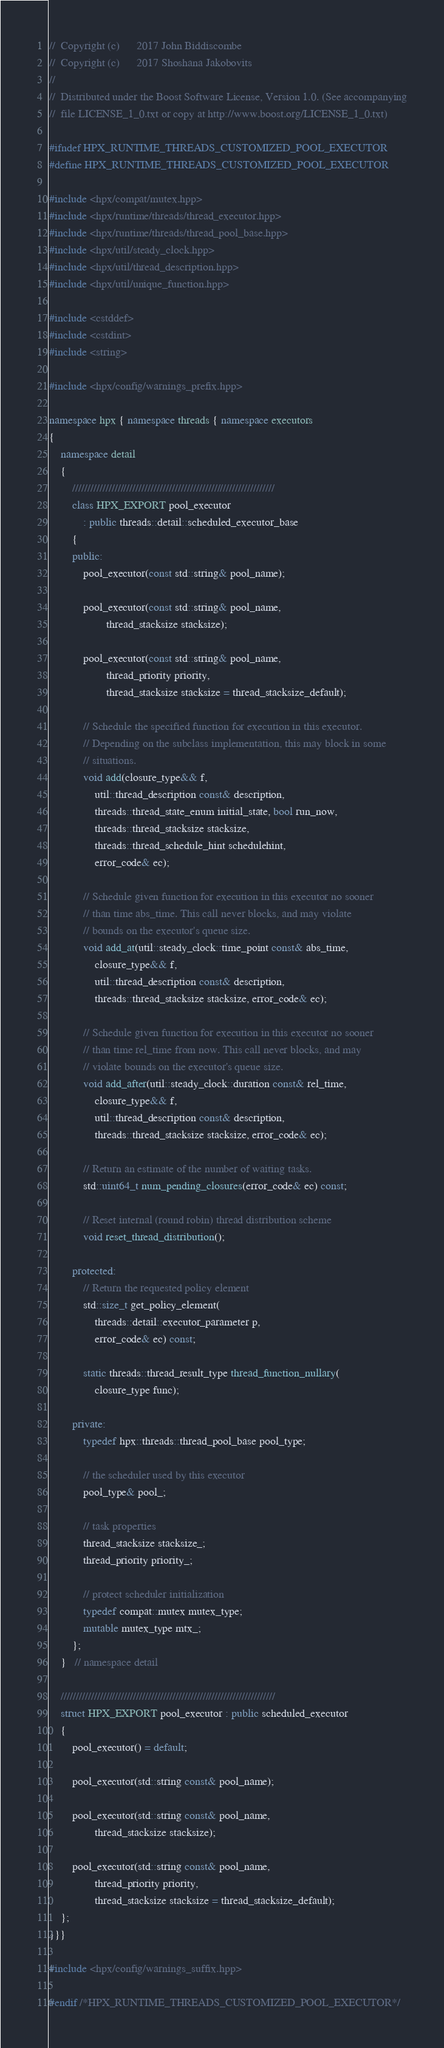<code> <loc_0><loc_0><loc_500><loc_500><_C++_>//  Copyright (c)      2017 John Biddiscombe
//  Copyright (c)      2017 Shoshana Jakobovits
//
//  Distributed under the Boost Software License, Version 1.0. (See accompanying
//  file LICENSE_1_0.txt or copy at http://www.boost.org/LICENSE_1_0.txt)

#ifndef HPX_RUNTIME_THREADS_CUSTOMIZED_POOL_EXECUTOR
#define HPX_RUNTIME_THREADS_CUSTOMIZED_POOL_EXECUTOR

#include <hpx/compat/mutex.hpp>
#include <hpx/runtime/threads/thread_executor.hpp>
#include <hpx/runtime/threads/thread_pool_base.hpp>
#include <hpx/util/steady_clock.hpp>
#include <hpx/util/thread_description.hpp>
#include <hpx/util/unique_function.hpp>

#include <cstddef>
#include <cstdint>
#include <string>

#include <hpx/config/warnings_prefix.hpp>

namespace hpx { namespace threads { namespace executors
{
    namespace detail
    {
        ///////////////////////////////////////////////////////////////////
        class HPX_EXPORT pool_executor
            : public threads::detail::scheduled_executor_base
        {
        public:
            pool_executor(const std::string& pool_name);

            pool_executor(const std::string& pool_name,
                    thread_stacksize stacksize);

            pool_executor(const std::string& pool_name,
                    thread_priority priority,
                    thread_stacksize stacksize = thread_stacksize_default);

            // Schedule the specified function for execution in this executor.
            // Depending on the subclass implementation, this may block in some
            // situations.
            void add(closure_type&& f,
                util::thread_description const& description,
                threads::thread_state_enum initial_state, bool run_now,
                threads::thread_stacksize stacksize,
                threads::thread_schedule_hint schedulehint,
                error_code& ec);

            // Schedule given function for execution in this executor no sooner
            // than time abs_time. This call never blocks, and may violate
            // bounds on the executor's queue size.
            void add_at(util::steady_clock::time_point const& abs_time,
                closure_type&& f,
                util::thread_description const& description,
                threads::thread_stacksize stacksize, error_code& ec);

            // Schedule given function for execution in this executor no sooner
            // than time rel_time from now. This call never blocks, and may
            // violate bounds on the executor's queue size.
            void add_after(util::steady_clock::duration const& rel_time,
                closure_type&& f,
                util::thread_description const& description,
                threads::thread_stacksize stacksize, error_code& ec);

            // Return an estimate of the number of waiting tasks.
            std::uint64_t num_pending_closures(error_code& ec) const;

            // Reset internal (round robin) thread distribution scheme
            void reset_thread_distribution();

        protected:
            // Return the requested policy element
            std::size_t get_policy_element(
                threads::detail::executor_parameter p,
                error_code& ec) const;

            static threads::thread_result_type thread_function_nullary(
                closure_type func);

        private:
            typedef hpx::threads::thread_pool_base pool_type;

            // the scheduler used by this executor
            pool_type& pool_;

            // task properties
            thread_stacksize stacksize_;
            thread_priority priority_;

            // protect scheduler initialization
            typedef compat::mutex mutex_type;
            mutable mutex_type mtx_;
        };
    }   // namespace detail

    ///////////////////////////////////////////////////////////////////////
    struct HPX_EXPORT pool_executor : public scheduled_executor
    {
        pool_executor() = default;

        pool_executor(std::string const& pool_name);

        pool_executor(std::string const& pool_name,
                thread_stacksize stacksize);

        pool_executor(std::string const& pool_name,
                thread_priority priority,
                thread_stacksize stacksize = thread_stacksize_default);
    };
}}}

#include <hpx/config/warnings_suffix.hpp>

#endif /*HPX_RUNTIME_THREADS_CUSTOMIZED_POOL_EXECUTOR*/
</code> 